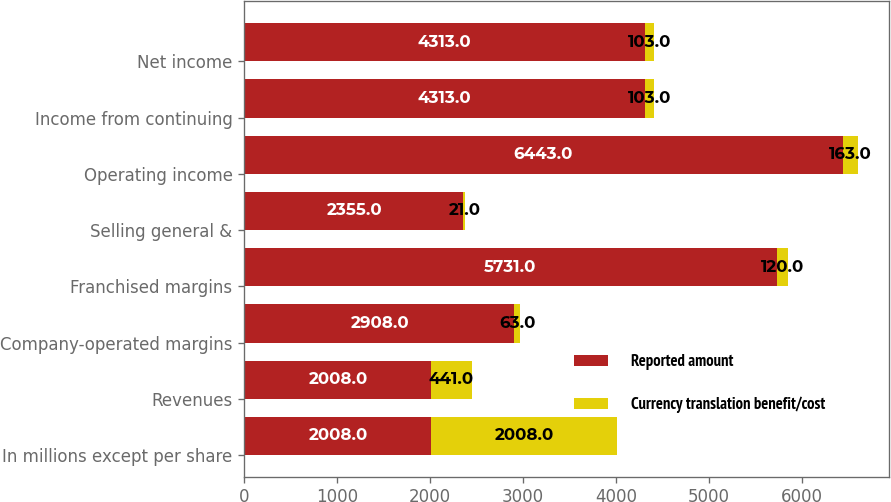Convert chart to OTSL. <chart><loc_0><loc_0><loc_500><loc_500><stacked_bar_chart><ecel><fcel>In millions except per share<fcel>Revenues<fcel>Company-operated margins<fcel>Franchised margins<fcel>Selling general &<fcel>Operating income<fcel>Income from continuing<fcel>Net income<nl><fcel>Reported amount<fcel>2008<fcel>2008<fcel>2908<fcel>5731<fcel>2355<fcel>6443<fcel>4313<fcel>4313<nl><fcel>Currency translation benefit/cost<fcel>2008<fcel>441<fcel>63<fcel>120<fcel>21<fcel>163<fcel>103<fcel>103<nl></chart> 